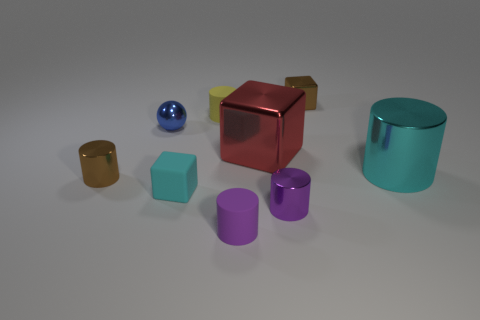Subtract all tiny metallic cylinders. How many cylinders are left? 3 Subtract all cyan cylinders. How many cylinders are left? 4 Add 1 small red matte spheres. How many objects exist? 10 Subtract all blue spheres. How many brown cylinders are left? 1 Add 8 cyan metal cylinders. How many cyan metal cylinders are left? 9 Add 5 large cyan cylinders. How many large cyan cylinders exist? 6 Subtract 1 blue spheres. How many objects are left? 8 Subtract all blocks. How many objects are left? 6 Subtract 5 cylinders. How many cylinders are left? 0 Subtract all blue cylinders. Subtract all blue cubes. How many cylinders are left? 5 